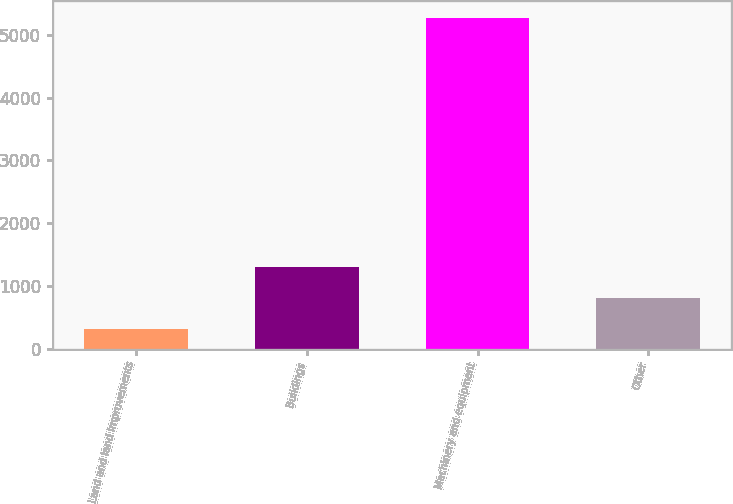Convert chart. <chart><loc_0><loc_0><loc_500><loc_500><bar_chart><fcel>Land and land improvements<fcel>Buildings<fcel>Machinery and equipment<fcel>Other<nl><fcel>309<fcel>1301.8<fcel>5273<fcel>805.4<nl></chart> 